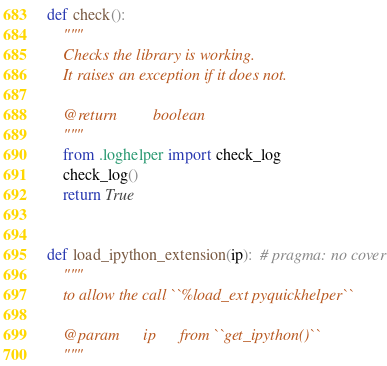<code> <loc_0><loc_0><loc_500><loc_500><_Python_>def check():
    """
    Checks the library is working.
    It raises an exception if it does not.

    @return         boolean
    """
    from .loghelper import check_log
    check_log()
    return True


def load_ipython_extension(ip):  # pragma: no cover
    """
    to allow the call ``%load_ext pyquickhelper``

    @param      ip      from ``get_ipython()``
    """</code> 